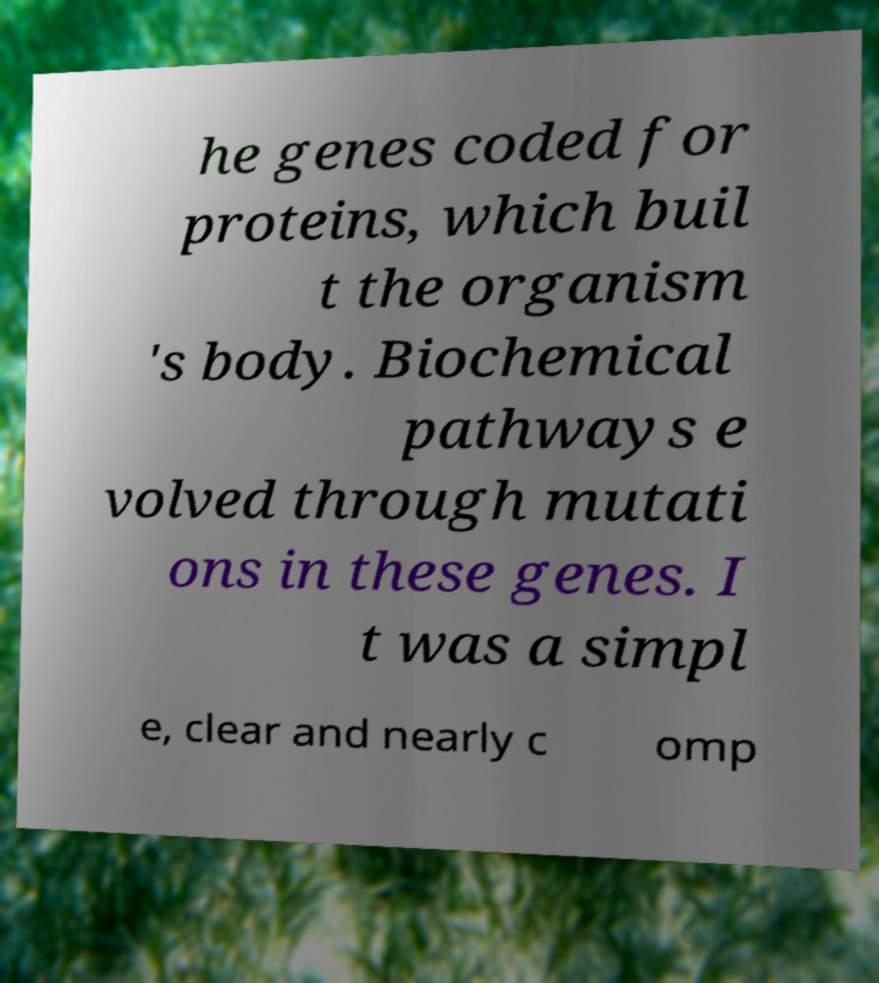Please identify and transcribe the text found in this image. he genes coded for proteins, which buil t the organism 's body. Biochemical pathways e volved through mutati ons in these genes. I t was a simpl e, clear and nearly c omp 